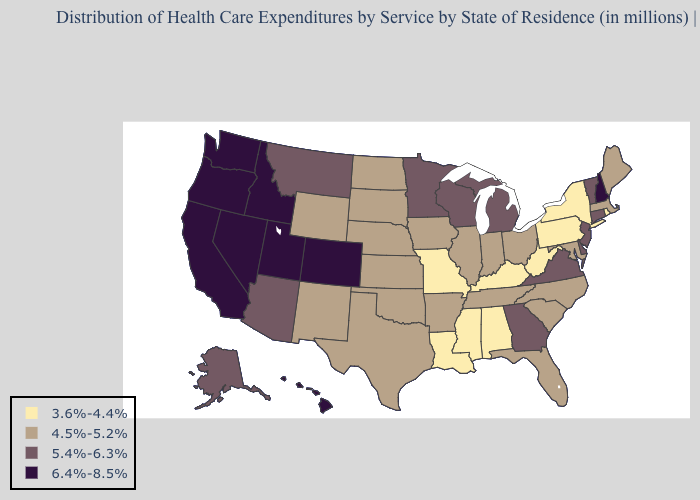Does Hawaii have a lower value than Kansas?
Give a very brief answer. No. What is the highest value in the MidWest ?
Answer briefly. 5.4%-6.3%. What is the value of Arkansas?
Be succinct. 4.5%-5.2%. Name the states that have a value in the range 4.5%-5.2%?
Write a very short answer. Arkansas, Florida, Illinois, Indiana, Iowa, Kansas, Maine, Maryland, Massachusetts, Nebraska, New Mexico, North Carolina, North Dakota, Ohio, Oklahoma, South Carolina, South Dakota, Tennessee, Texas, Wyoming. Among the states that border Florida , which have the highest value?
Give a very brief answer. Georgia. What is the lowest value in states that border Nebraska?
Write a very short answer. 3.6%-4.4%. Does Mississippi have the lowest value in the USA?
Concise answer only. Yes. What is the lowest value in the MidWest?
Concise answer only. 3.6%-4.4%. What is the highest value in the USA?
Write a very short answer. 6.4%-8.5%. Name the states that have a value in the range 6.4%-8.5%?
Keep it brief. California, Colorado, Hawaii, Idaho, Nevada, New Hampshire, Oregon, Utah, Washington. Name the states that have a value in the range 5.4%-6.3%?
Short answer required. Alaska, Arizona, Connecticut, Delaware, Georgia, Michigan, Minnesota, Montana, New Jersey, Vermont, Virginia, Wisconsin. Among the states that border Nevada , which have the lowest value?
Short answer required. Arizona. Does Massachusetts have the same value as Maine?
Short answer required. Yes. Name the states that have a value in the range 6.4%-8.5%?
Concise answer only. California, Colorado, Hawaii, Idaho, Nevada, New Hampshire, Oregon, Utah, Washington. Name the states that have a value in the range 3.6%-4.4%?
Give a very brief answer. Alabama, Kentucky, Louisiana, Mississippi, Missouri, New York, Pennsylvania, Rhode Island, West Virginia. 